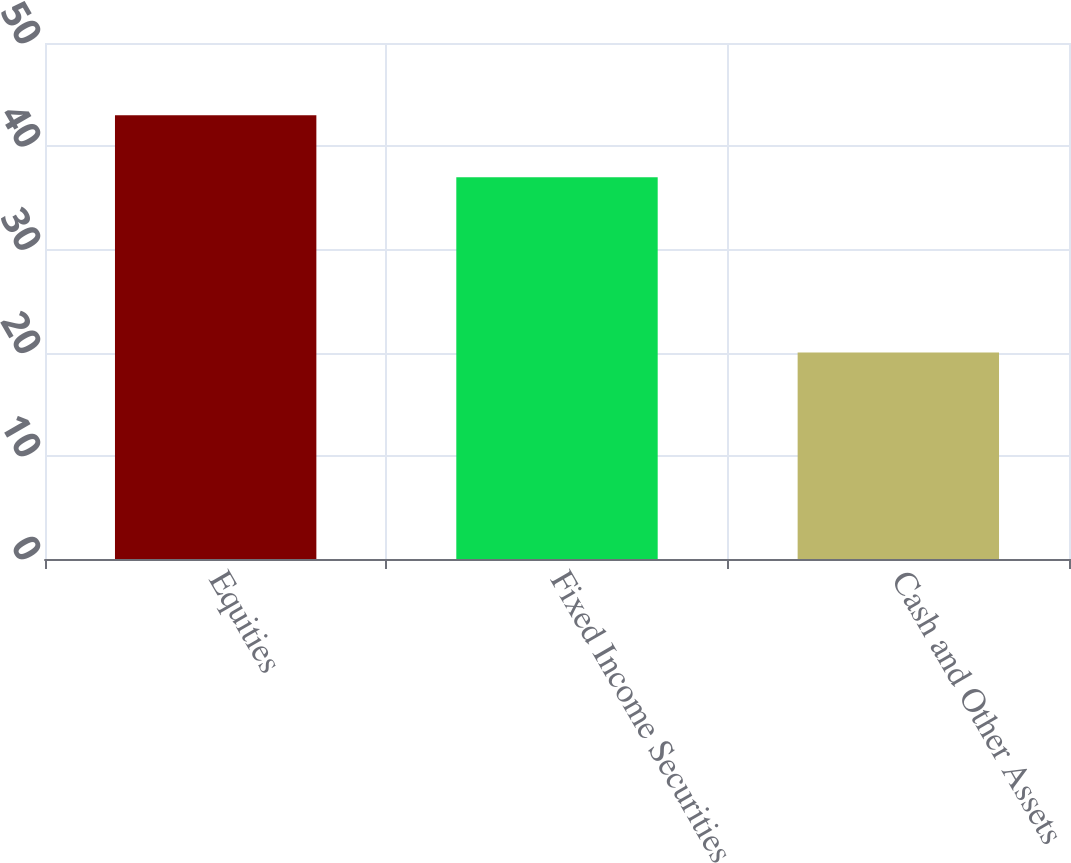Convert chart to OTSL. <chart><loc_0><loc_0><loc_500><loc_500><bar_chart><fcel>Equities<fcel>Fixed Income Securities<fcel>Cash and Other Assets<nl><fcel>43<fcel>37<fcel>20<nl></chart> 